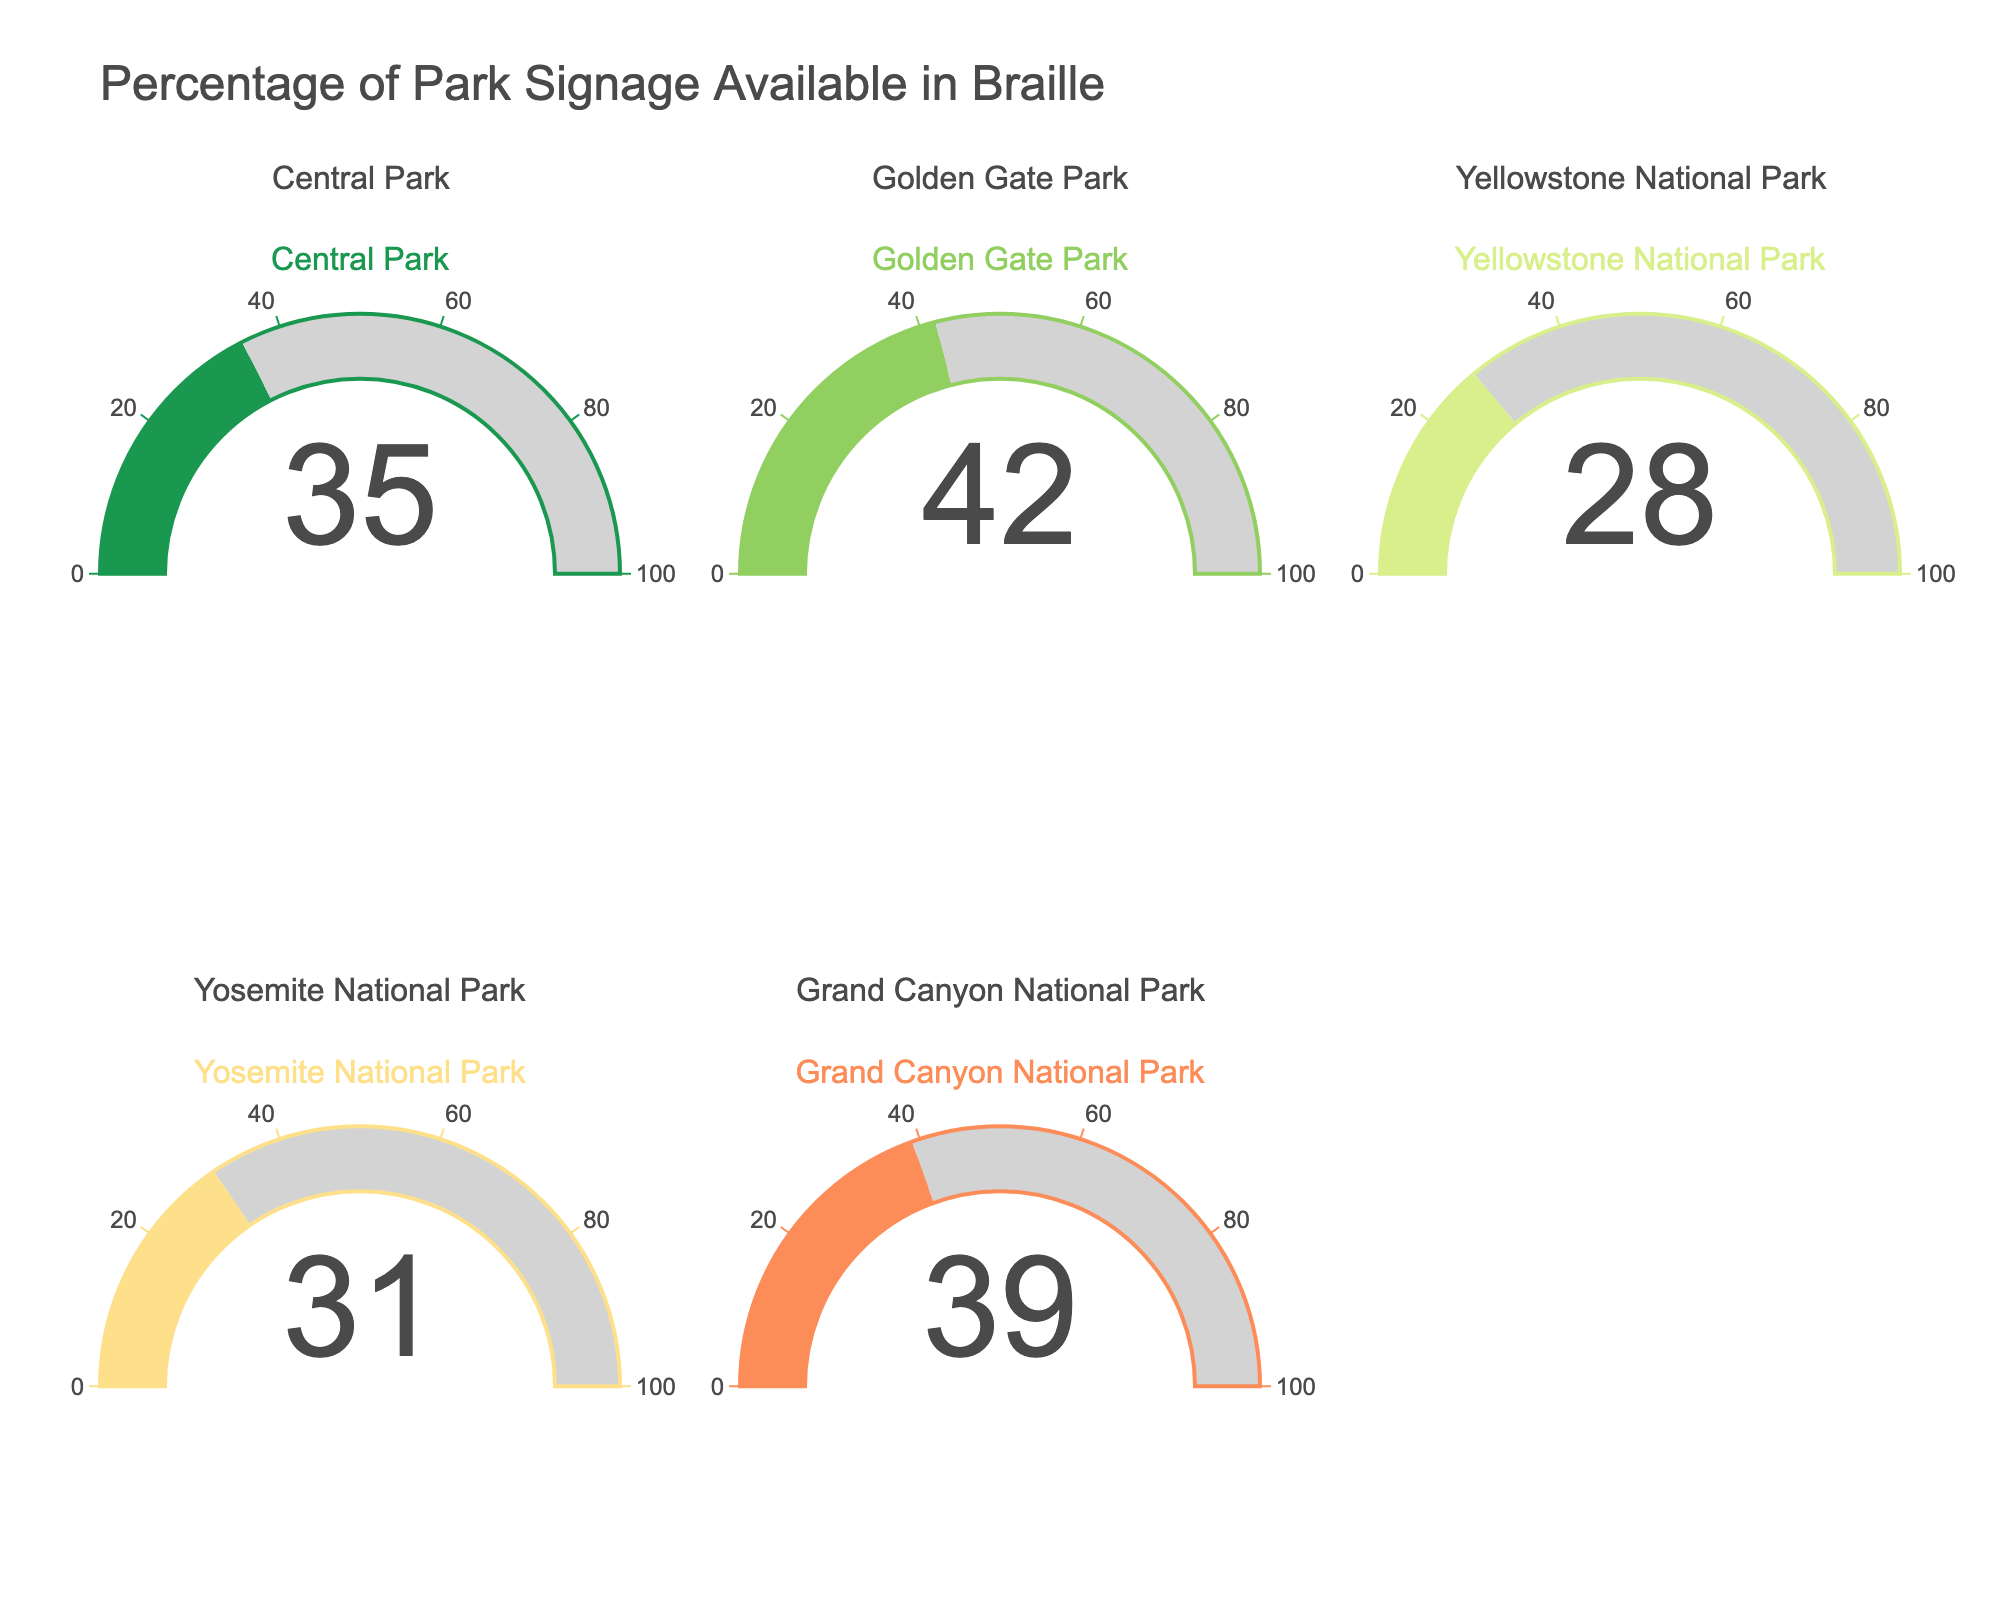What's the title of the figure? The title of the figure is usually displayed at the top. It summarizes the main focus of the figure, helping viewers quickly understand what the chart represents.
Answer: Percentage of Park Signage Available in Braille How many parks are represented in the figure? By counting the distinct gauges, we can determine the number of parks represented. Each gauge corresponds to one park.
Answer: 5 Which park has the lowest percentage of braille signage? By observing the gauge values for each park, we can find the one with the smallest percentage value.
Answer: Yellowstone National Park What's the average percentage of braille signage across all parks? To find the average, sum the percentages of all parks and divide by the number of parks. (35 + 42 + 28 + 31 + 39) / 5 = 35
Answer: 35 Which parks have a percentage of braille signage above 30%? Identify the parks whose gauges display a value greater than 30.
Answer: Central Park, Golden Gate Park, Grand Canyon National Park What's the difference in the percentage of braille signage between the park with the highest and lowest values? Find the highest and lowest percentage values and subtract the latter from the former. 42 - 28 = 14
Answer: 14 What color is used for Grand Canyon National Park's gauge? The color of each gauge is a visual element that can be directly observed. For Grand Canyon, it should be the unique color used in its gauge.
Answer: #fc8d59 Which park has a percentage of braille signage closest to the average of all parks? Calculate the distance of each park's percentage from the average (35) and find the park with the smallest distance. Central (35), Yosemite (31), Grand Canyon (39). Closest is either Central (0) or Grand Canyon (4).
Answer: Central Park What is the combined total percentage of braille signage for Central Park and Golden Gate Park? Add the percentage values of the two parks. 35 + 42 = 77
Answer: 77 How many parks have less than 40% of their signage available in braille? Count the gauges with values less than 40. Yellowstone (28), Yosemite (31), and Central (35), Grand Canyon (39). Four parks in total.
Answer: 4 